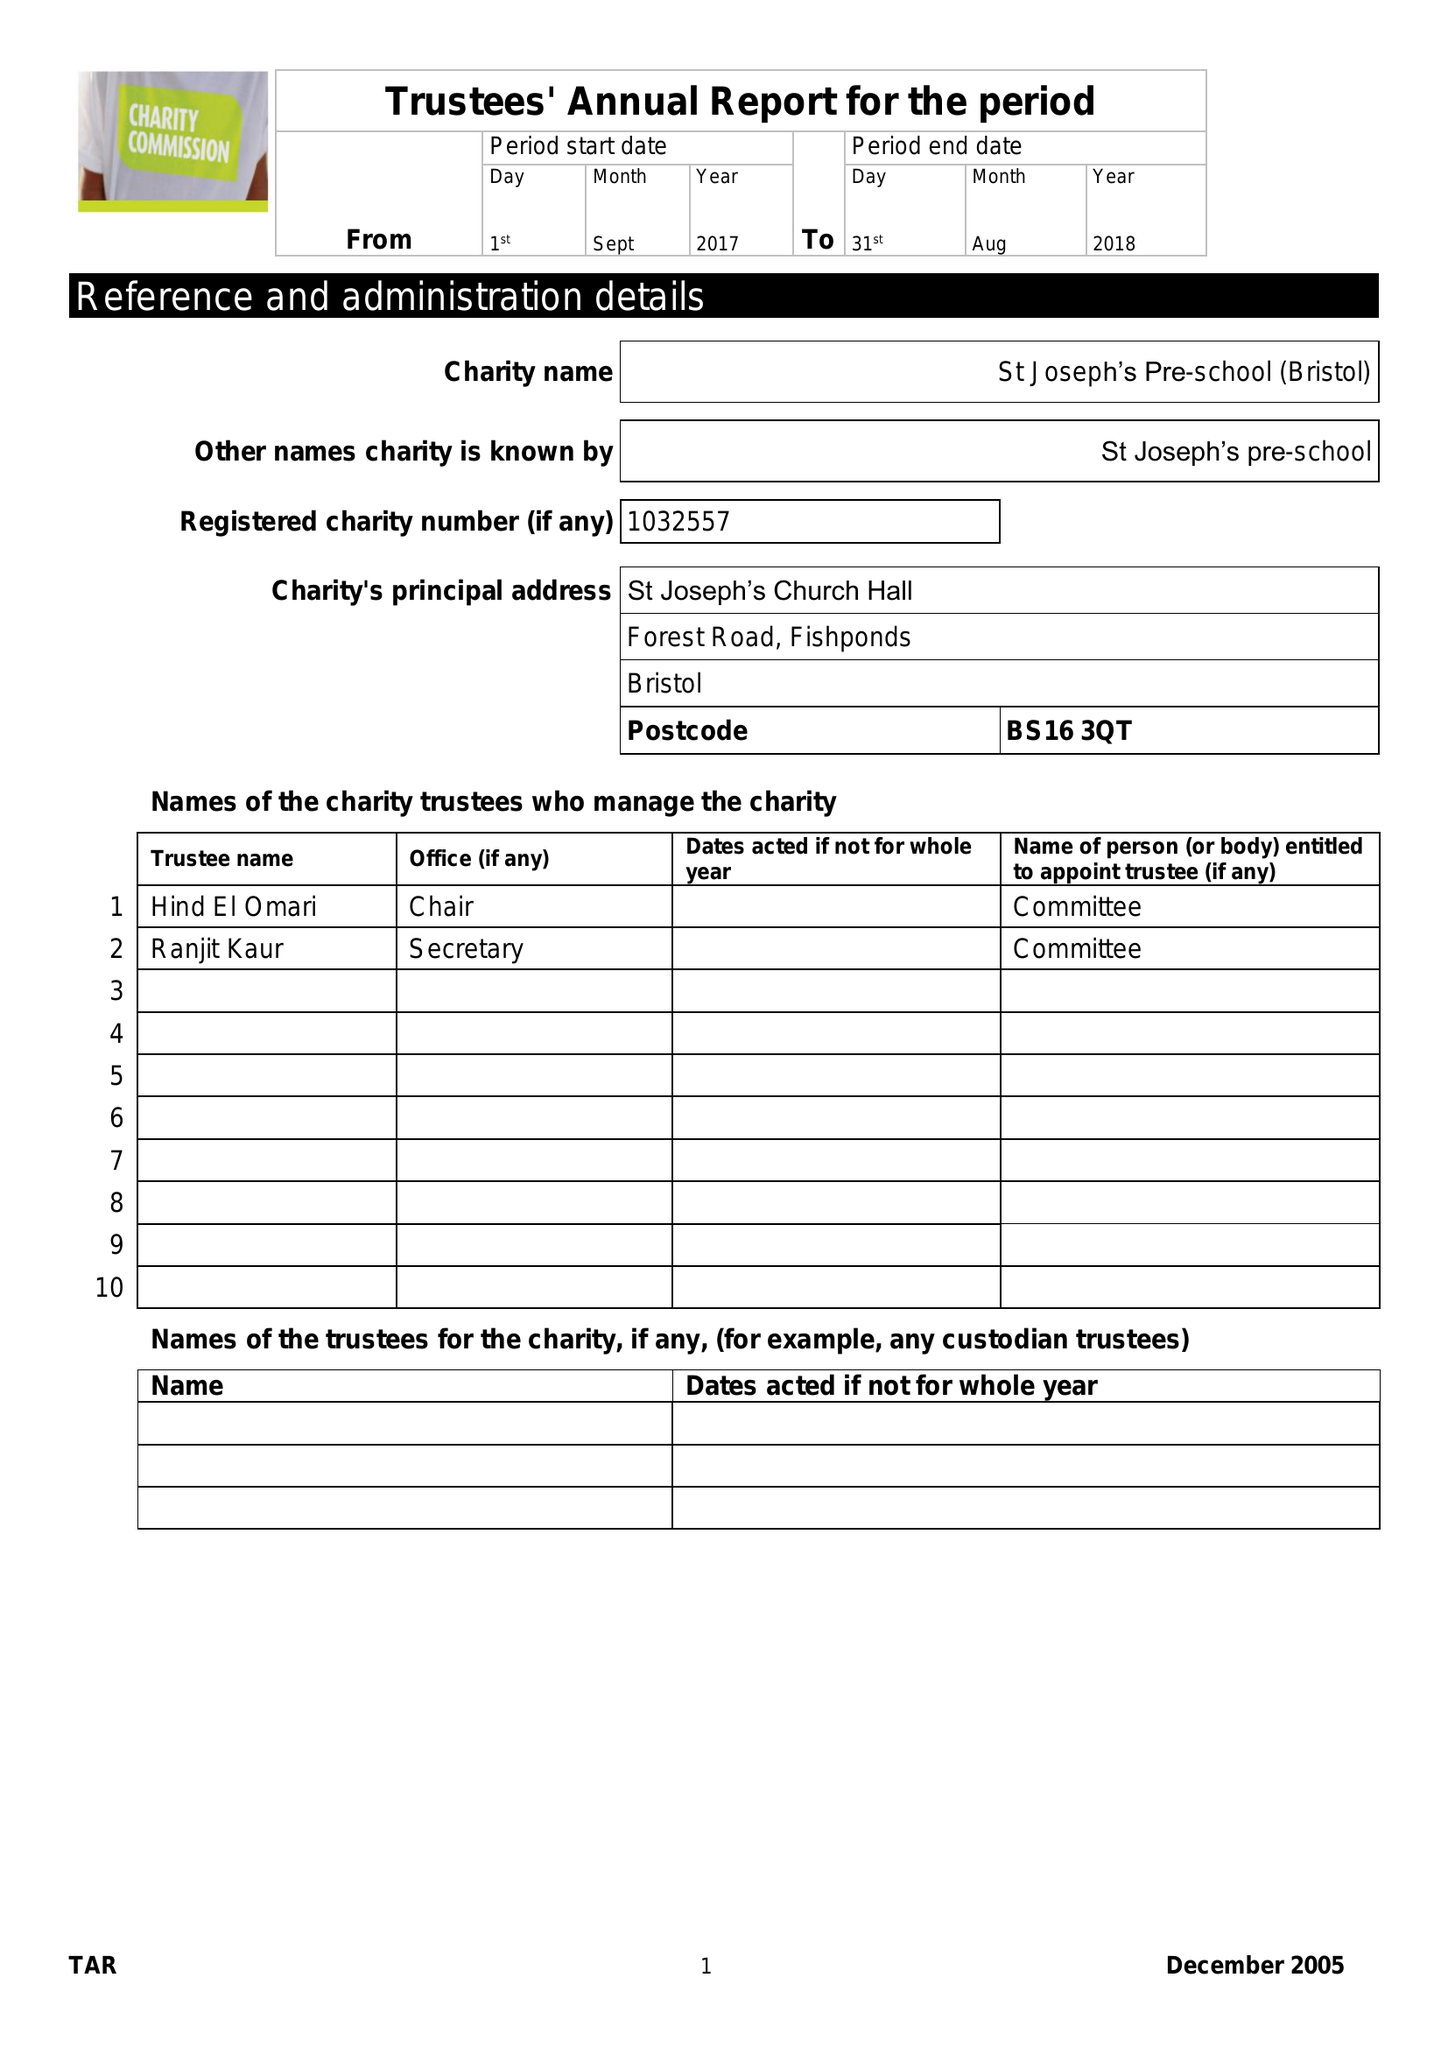What is the value for the address__postcode?
Answer the question using a single word or phrase. BS16 3QT 